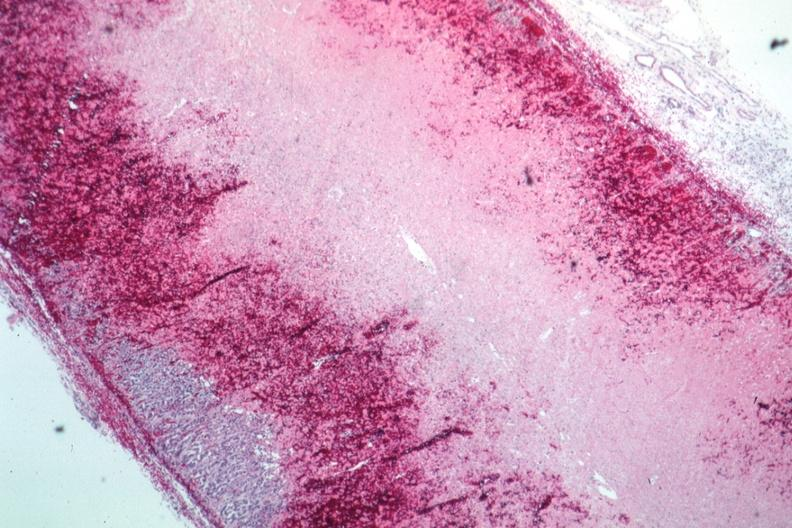does this image show infarction and hemorrhage well shown?
Answer the question using a single word or phrase. Yes 